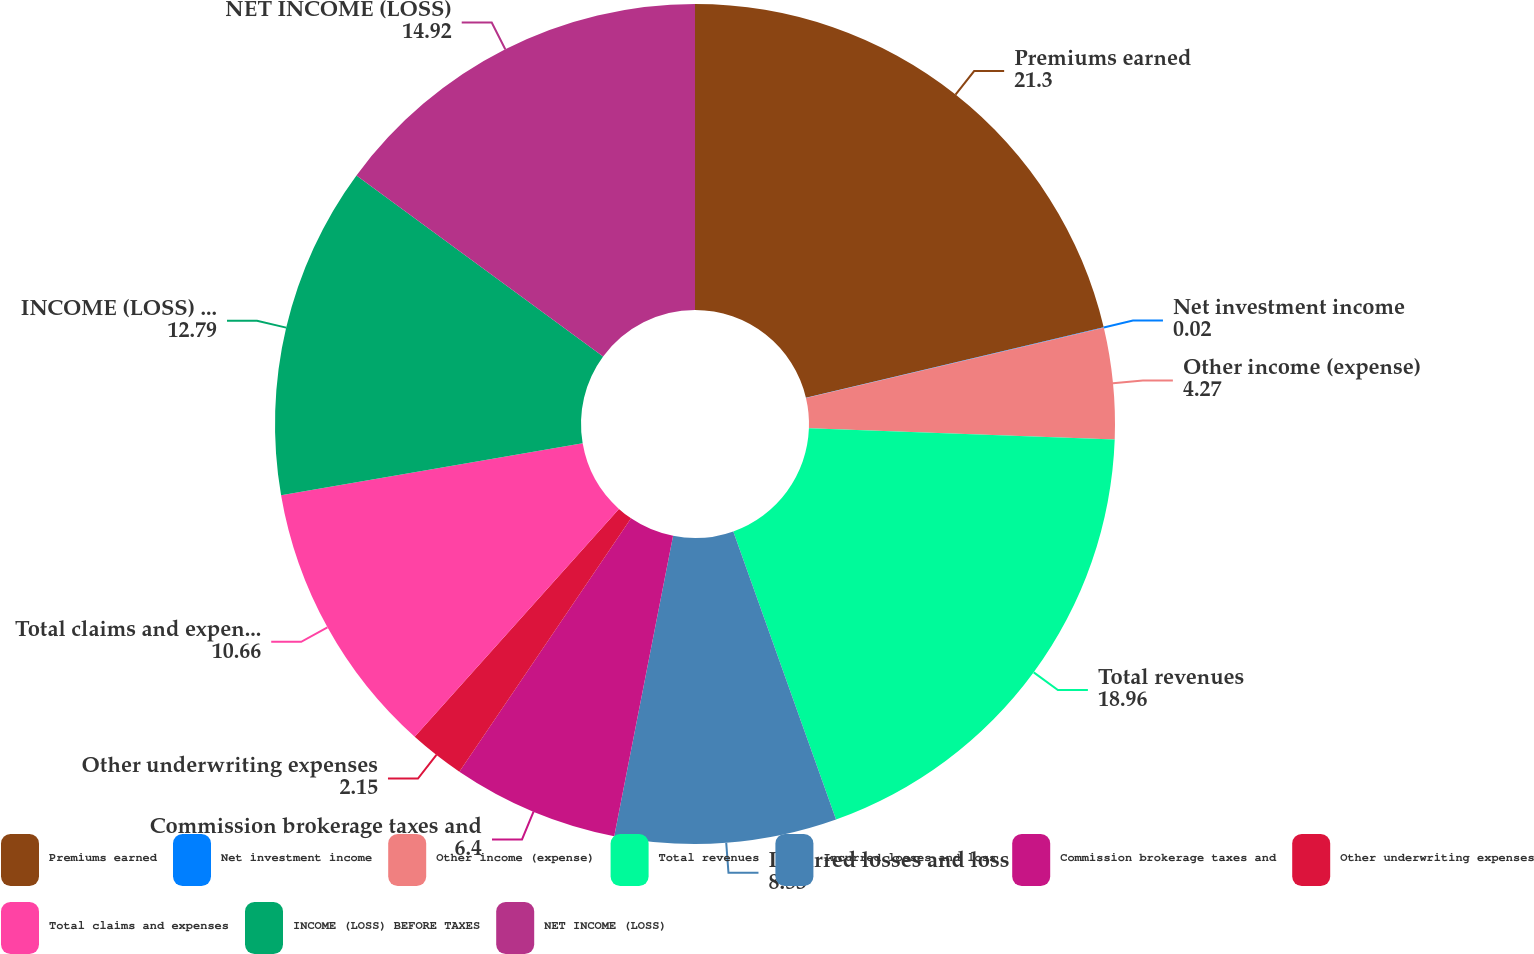Convert chart to OTSL. <chart><loc_0><loc_0><loc_500><loc_500><pie_chart><fcel>Premiums earned<fcel>Net investment income<fcel>Other income (expense)<fcel>Total revenues<fcel>Incurred losses and loss<fcel>Commission brokerage taxes and<fcel>Other underwriting expenses<fcel>Total claims and expenses<fcel>INCOME (LOSS) BEFORE TAXES<fcel>NET INCOME (LOSS)<nl><fcel>21.3%<fcel>0.02%<fcel>4.27%<fcel>18.96%<fcel>8.53%<fcel>6.4%<fcel>2.15%<fcel>10.66%<fcel>12.79%<fcel>14.92%<nl></chart> 